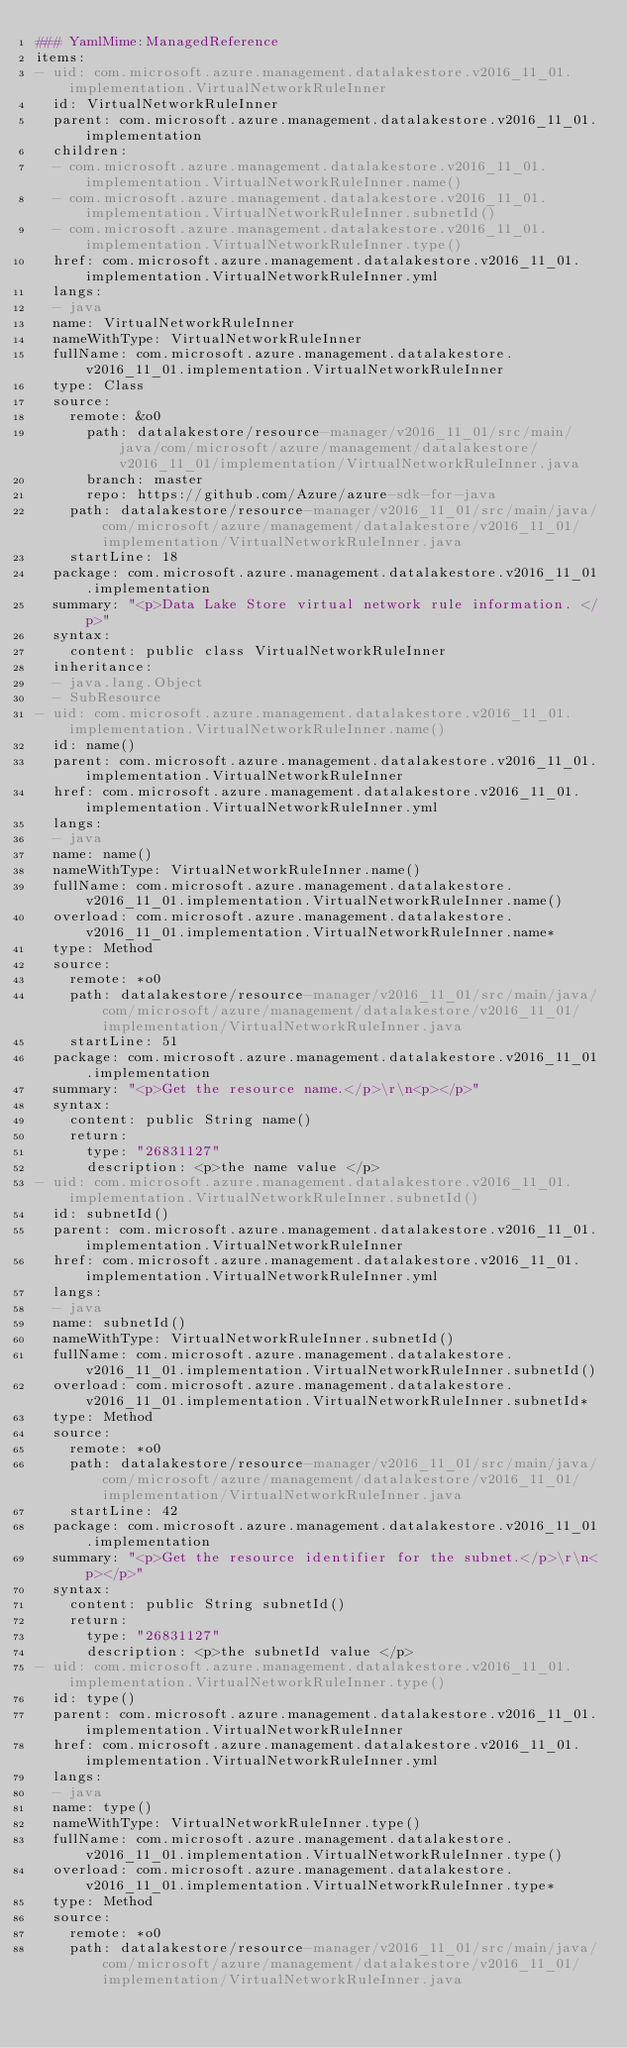<code> <loc_0><loc_0><loc_500><loc_500><_YAML_>### YamlMime:ManagedReference
items:
- uid: com.microsoft.azure.management.datalakestore.v2016_11_01.implementation.VirtualNetworkRuleInner
  id: VirtualNetworkRuleInner
  parent: com.microsoft.azure.management.datalakestore.v2016_11_01.implementation
  children:
  - com.microsoft.azure.management.datalakestore.v2016_11_01.implementation.VirtualNetworkRuleInner.name()
  - com.microsoft.azure.management.datalakestore.v2016_11_01.implementation.VirtualNetworkRuleInner.subnetId()
  - com.microsoft.azure.management.datalakestore.v2016_11_01.implementation.VirtualNetworkRuleInner.type()
  href: com.microsoft.azure.management.datalakestore.v2016_11_01.implementation.VirtualNetworkRuleInner.yml
  langs:
  - java
  name: VirtualNetworkRuleInner
  nameWithType: VirtualNetworkRuleInner
  fullName: com.microsoft.azure.management.datalakestore.v2016_11_01.implementation.VirtualNetworkRuleInner
  type: Class
  source:
    remote: &o0
      path: datalakestore/resource-manager/v2016_11_01/src/main/java/com/microsoft/azure/management/datalakestore/v2016_11_01/implementation/VirtualNetworkRuleInner.java
      branch: master
      repo: https://github.com/Azure/azure-sdk-for-java
    path: datalakestore/resource-manager/v2016_11_01/src/main/java/com/microsoft/azure/management/datalakestore/v2016_11_01/implementation/VirtualNetworkRuleInner.java
    startLine: 18
  package: com.microsoft.azure.management.datalakestore.v2016_11_01.implementation
  summary: "<p>Data Lake Store virtual network rule information. </p>"
  syntax:
    content: public class VirtualNetworkRuleInner
  inheritance:
  - java.lang.Object
  - SubResource
- uid: com.microsoft.azure.management.datalakestore.v2016_11_01.implementation.VirtualNetworkRuleInner.name()
  id: name()
  parent: com.microsoft.azure.management.datalakestore.v2016_11_01.implementation.VirtualNetworkRuleInner
  href: com.microsoft.azure.management.datalakestore.v2016_11_01.implementation.VirtualNetworkRuleInner.yml
  langs:
  - java
  name: name()
  nameWithType: VirtualNetworkRuleInner.name()
  fullName: com.microsoft.azure.management.datalakestore.v2016_11_01.implementation.VirtualNetworkRuleInner.name()
  overload: com.microsoft.azure.management.datalakestore.v2016_11_01.implementation.VirtualNetworkRuleInner.name*
  type: Method
  source:
    remote: *o0
    path: datalakestore/resource-manager/v2016_11_01/src/main/java/com/microsoft/azure/management/datalakestore/v2016_11_01/implementation/VirtualNetworkRuleInner.java
    startLine: 51
  package: com.microsoft.azure.management.datalakestore.v2016_11_01.implementation
  summary: "<p>Get the resource name.</p>\r\n<p></p>"
  syntax:
    content: public String name()
    return:
      type: "26831127"
      description: <p>the name value </p>
- uid: com.microsoft.azure.management.datalakestore.v2016_11_01.implementation.VirtualNetworkRuleInner.subnetId()
  id: subnetId()
  parent: com.microsoft.azure.management.datalakestore.v2016_11_01.implementation.VirtualNetworkRuleInner
  href: com.microsoft.azure.management.datalakestore.v2016_11_01.implementation.VirtualNetworkRuleInner.yml
  langs:
  - java
  name: subnetId()
  nameWithType: VirtualNetworkRuleInner.subnetId()
  fullName: com.microsoft.azure.management.datalakestore.v2016_11_01.implementation.VirtualNetworkRuleInner.subnetId()
  overload: com.microsoft.azure.management.datalakestore.v2016_11_01.implementation.VirtualNetworkRuleInner.subnetId*
  type: Method
  source:
    remote: *o0
    path: datalakestore/resource-manager/v2016_11_01/src/main/java/com/microsoft/azure/management/datalakestore/v2016_11_01/implementation/VirtualNetworkRuleInner.java
    startLine: 42
  package: com.microsoft.azure.management.datalakestore.v2016_11_01.implementation
  summary: "<p>Get the resource identifier for the subnet.</p>\r\n<p></p>"
  syntax:
    content: public String subnetId()
    return:
      type: "26831127"
      description: <p>the subnetId value </p>
- uid: com.microsoft.azure.management.datalakestore.v2016_11_01.implementation.VirtualNetworkRuleInner.type()
  id: type()
  parent: com.microsoft.azure.management.datalakestore.v2016_11_01.implementation.VirtualNetworkRuleInner
  href: com.microsoft.azure.management.datalakestore.v2016_11_01.implementation.VirtualNetworkRuleInner.yml
  langs:
  - java
  name: type()
  nameWithType: VirtualNetworkRuleInner.type()
  fullName: com.microsoft.azure.management.datalakestore.v2016_11_01.implementation.VirtualNetworkRuleInner.type()
  overload: com.microsoft.azure.management.datalakestore.v2016_11_01.implementation.VirtualNetworkRuleInner.type*
  type: Method
  source:
    remote: *o0
    path: datalakestore/resource-manager/v2016_11_01/src/main/java/com/microsoft/azure/management/datalakestore/v2016_11_01/implementation/VirtualNetworkRuleInner.java</code> 